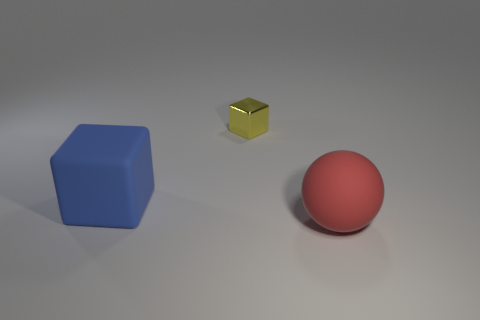Are there any other things that have the same material as the small cube?
Ensure brevity in your answer.  No. There is a matte thing that is in front of the matte object that is behind the rubber object right of the metallic block; what shape is it?
Provide a succinct answer. Sphere. How many things are either gray matte objects or large blue matte cubes that are on the left side of the small object?
Give a very brief answer. 1. There is a rubber object that is behind the red thing; does it have the same size as the red ball?
Provide a short and direct response. Yes. There is a thing that is in front of the big block; what material is it?
Provide a short and direct response. Rubber. Are there an equal number of large blue matte cubes that are in front of the blue matte block and matte things to the right of the rubber sphere?
Ensure brevity in your answer.  Yes. What color is the other tiny object that is the same shape as the blue rubber object?
Ensure brevity in your answer.  Yellow. How many rubber objects are either tiny yellow objects or red cylinders?
Your response must be concise. 0. Are there more big objects that are to the left of the large red matte thing than cyan objects?
Ensure brevity in your answer.  Yes. How many other things are there of the same material as the sphere?
Give a very brief answer. 1. 